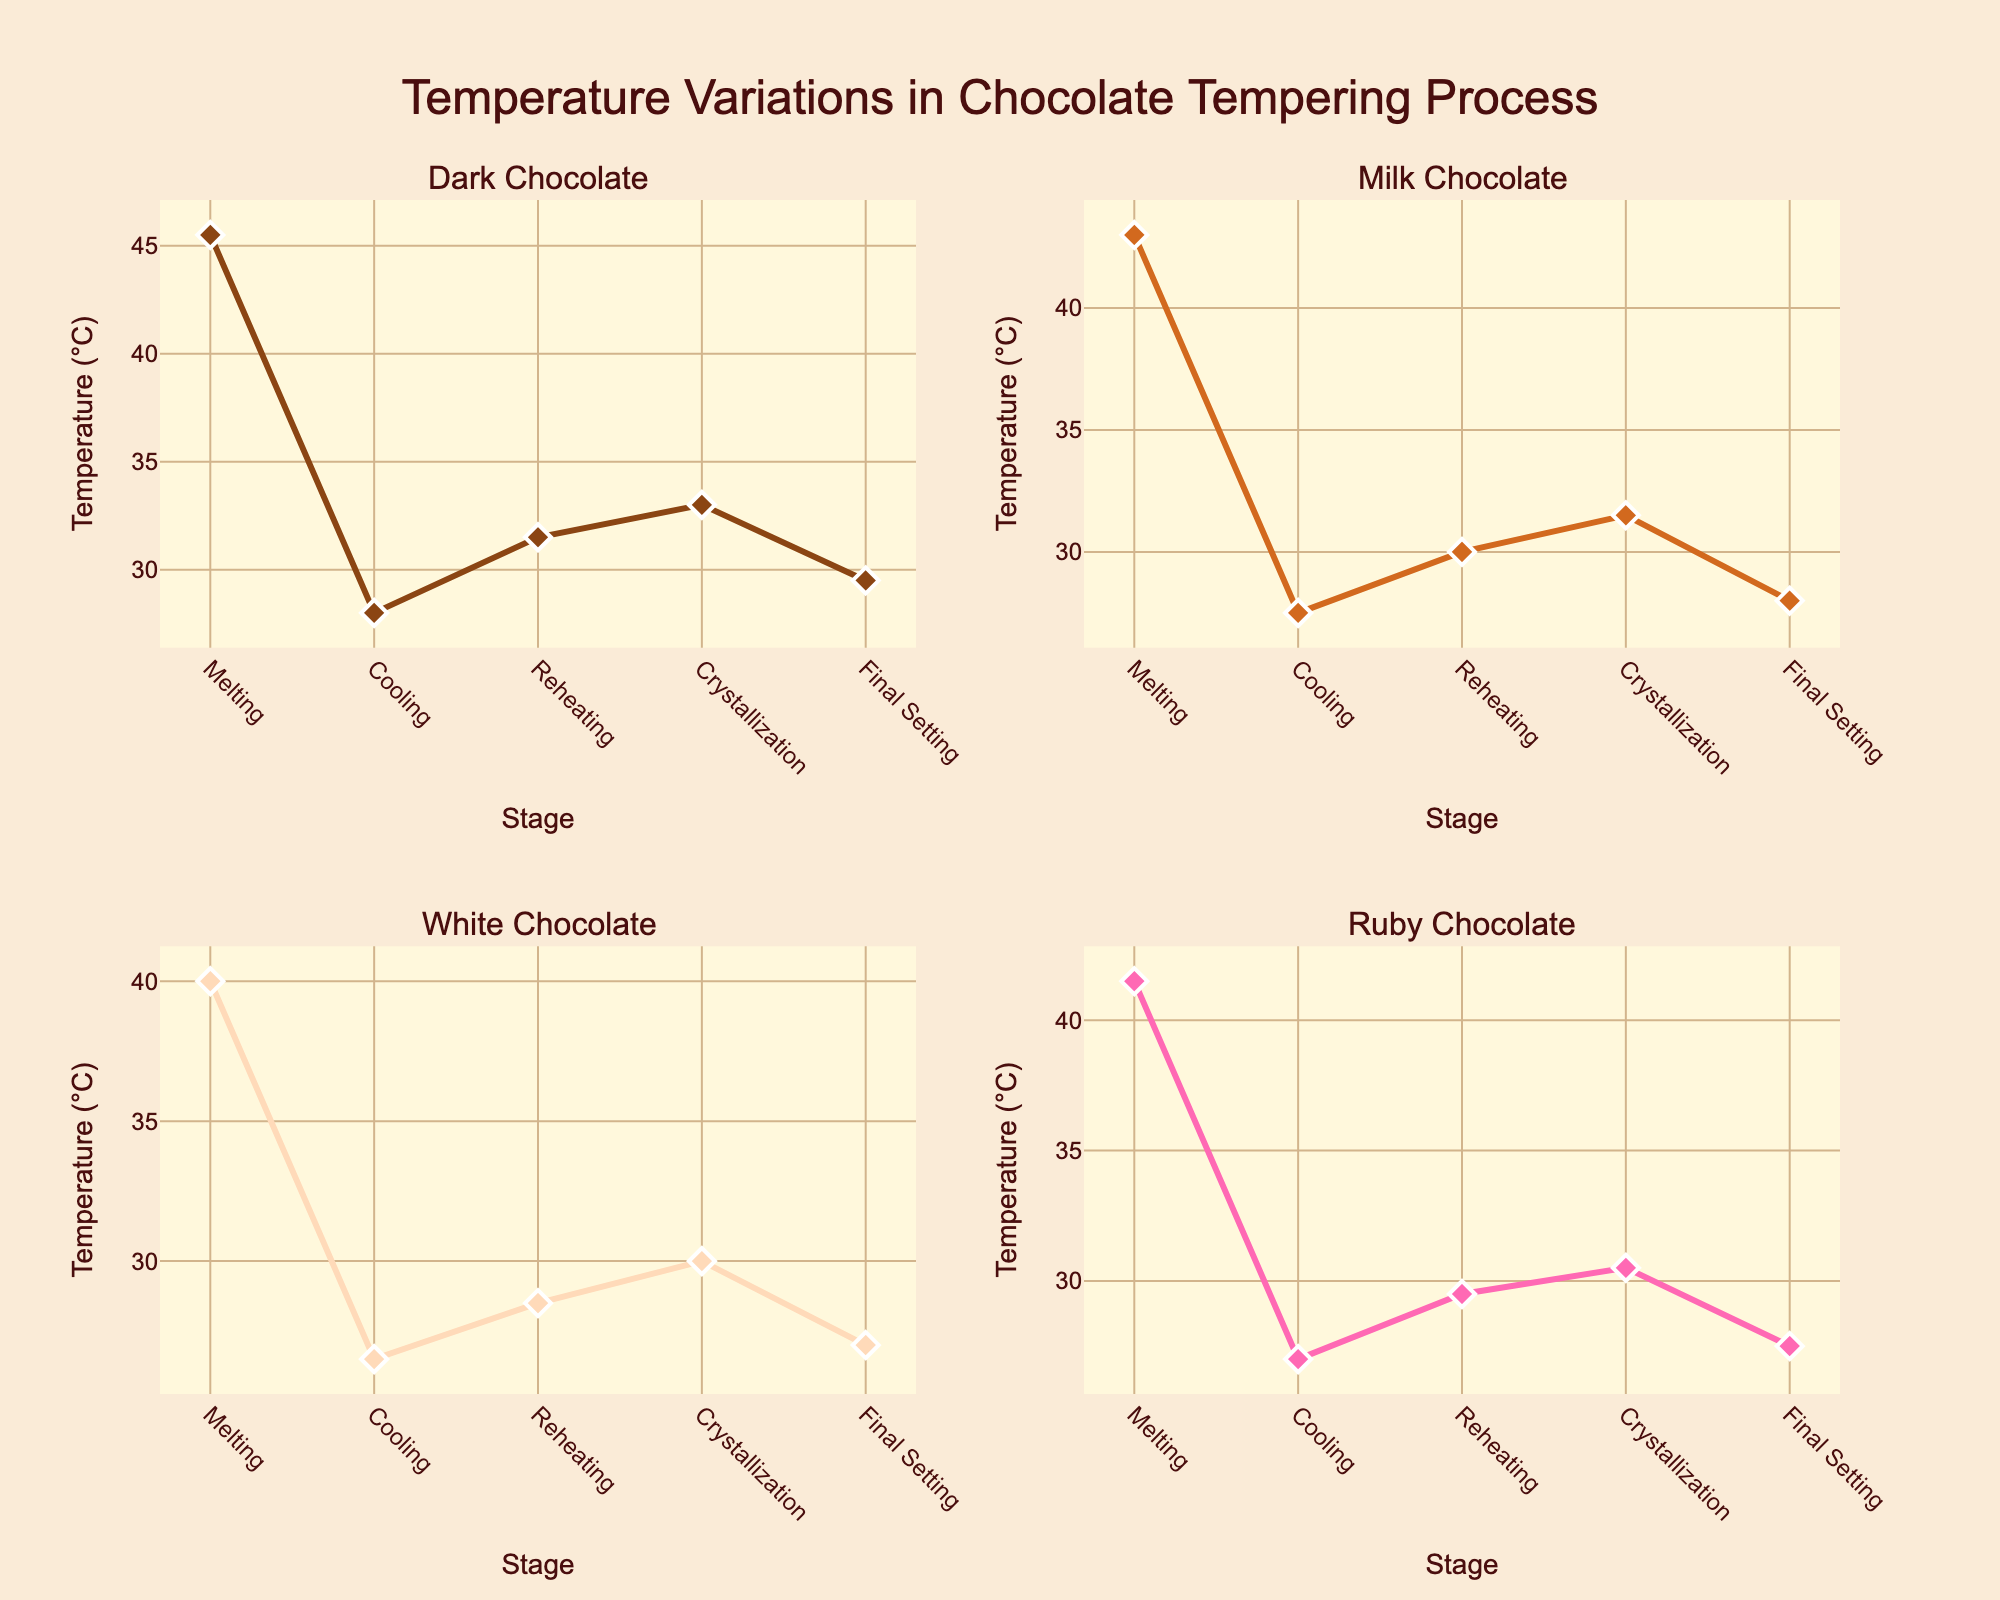Which stage has the highest temperature for Dark Chocolate? The highest temperature for Dark Chocolate is at the Melting stage, where it reaches 45.5°C, as indicated on the y-axis of the respective subplot.
Answer: Melting What is the temperature for White Chocolate during Reheating, and how does it compare to Ruby Chocolate during the same stage? The subplot for White Chocolate shows a temperature of 28.5°C during Reheating. In comparison, the Ruby Chocolate subplot shows a temperature of 29.5°C. Therefore, Ruby Chocolate has a higher temperature than White Chocolate during Reheating.
Answer: White: 28.5°C, Ruby: 29.5°C Which chocolate type has the lowest temperature during the Final Setting stage? By looking at the subplots for the Final Setting stage, White Chocolate has the lowest temperature at 27.0°C, as shown on the y-axis of its subplot.
Answer: White Chocolate What is the average temperature of Milk Chocolate across all stages? Add the temperatures of Milk Chocolate for all stages: 43.0 + 27.5 + 30.0 + 31.5 + 28.0 = 160.0. Divide by the number of stages, which is 5: 160.0 / 5 = 32.0.
Answer: 32.0°C Compare the temperature differences between the Melting and Cooling stages for Dark Chocolate and Milk Chocolate. Which has a greater change? For Dark Chocolate, the difference is 45.5 - 28.0 = 17.5°C. For Milk Chocolate, the difference is 43.0 - 27.5 = 15.5°C. Dark Chocolate has a greater change of 17.5°C compared to Milk Chocolate's 15.5°C.
Answer: Dark Chocolate What is the trend observed in temperatures for Ruby Chocolate across all stages? The trend can be observed by looking at the temperatures for each stage in Ruby Chocolate's subplot: the temperature decreases from Melting to Cooling, slightly increases during Reheating and Crystallization, and decreases again in the Final Setting stage.
Answer: Decrease, slight increase, then decrease What is the difference in temperature between the Crystallization and Final Setting stages for Milk Chocolate? The temperature for Milk Chocolate during Crystallization is 31.5°C and during Final Setting is 28.0°C. The difference is 31.5 - 28.0 = 3.5°C.
Answer: 3.5°C 